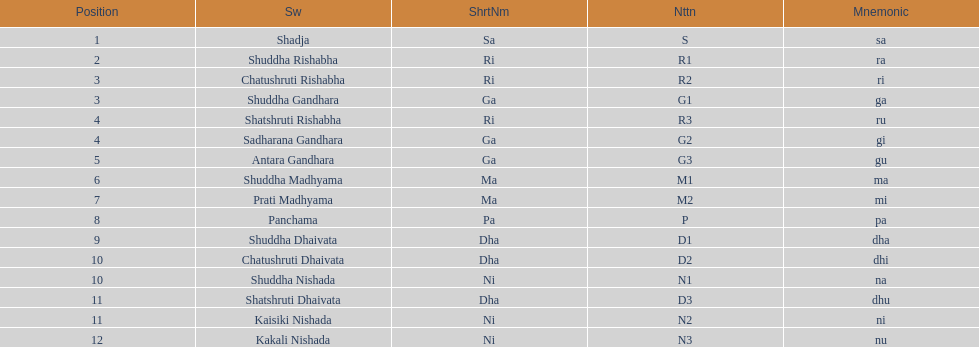What is the name of the swara that comes after panchama? Shuddha Dhaivata. 